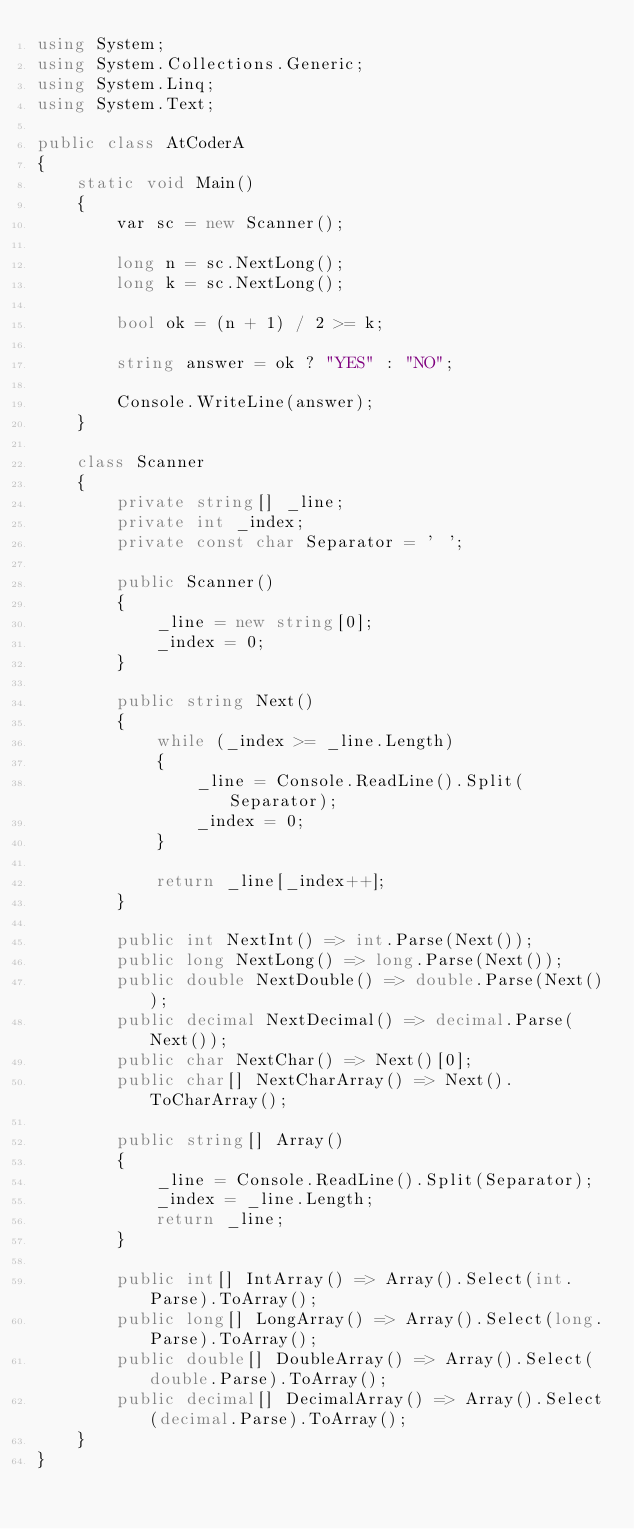<code> <loc_0><loc_0><loc_500><loc_500><_C#_>using System;
using System.Collections.Generic;
using System.Linq;
using System.Text;

public class AtCoderA
{
    static void Main()
    {
        var sc = new Scanner();

        long n = sc.NextLong();
        long k = sc.NextLong();

        bool ok = (n + 1) / 2 >= k;

        string answer = ok ? "YES" : "NO";

        Console.WriteLine(answer);
    }

    class Scanner
    {
        private string[] _line;
        private int _index;
        private const char Separator = ' ';

        public Scanner()
        {
            _line = new string[0];
            _index = 0;
        }

        public string Next()
        {
            while (_index >= _line.Length)
            {
                _line = Console.ReadLine().Split(Separator);
                _index = 0;
            }

            return _line[_index++];
        }

        public int NextInt() => int.Parse(Next());
        public long NextLong() => long.Parse(Next());
        public double NextDouble() => double.Parse(Next());
        public decimal NextDecimal() => decimal.Parse(Next());
        public char NextChar() => Next()[0];
        public char[] NextCharArray() => Next().ToCharArray();

        public string[] Array()
        {
            _line = Console.ReadLine().Split(Separator);
            _index = _line.Length;
            return _line;
        }

        public int[] IntArray() => Array().Select(int.Parse).ToArray();
        public long[] LongArray() => Array().Select(long.Parse).ToArray();
        public double[] DoubleArray() => Array().Select(double.Parse).ToArray();
        public decimal[] DecimalArray() => Array().Select(decimal.Parse).ToArray();
    }
}
</code> 